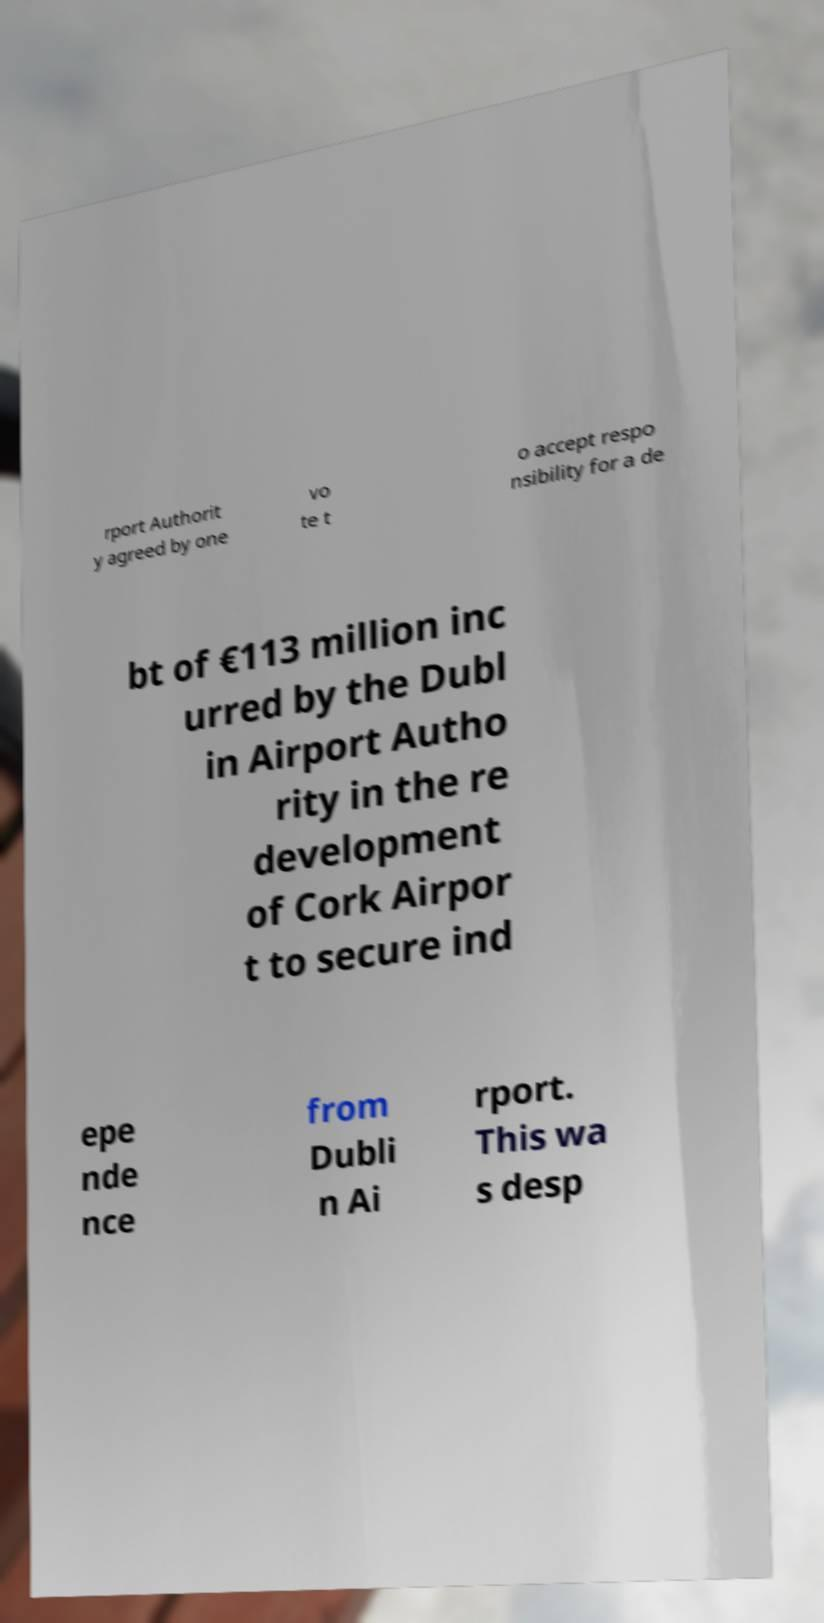What messages or text are displayed in this image? I need them in a readable, typed format. rport Authorit y agreed by one vo te t o accept respo nsibility for a de bt of €113 million inc urred by the Dubl in Airport Autho rity in the re development of Cork Airpor t to secure ind epe nde nce from Dubli n Ai rport. This wa s desp 